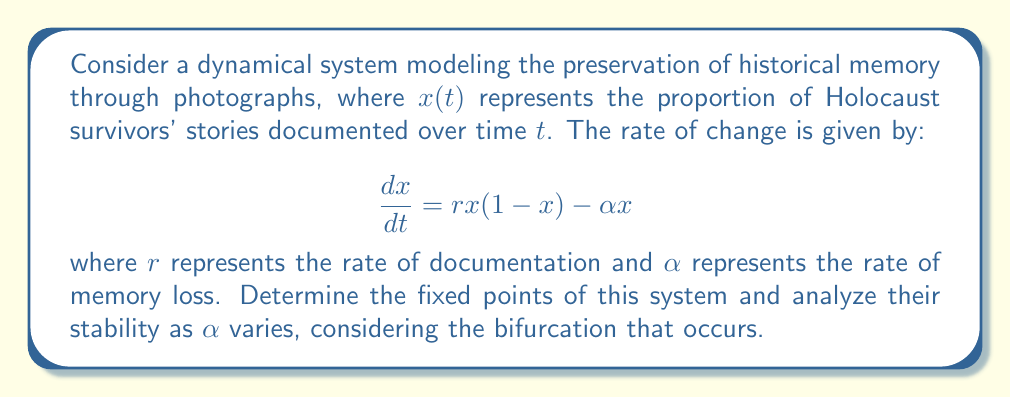Can you answer this question? 1. Find the fixed points by setting $\frac{dx}{dt} = 0$:
   $$rx(1-x) - \alpha x = 0$$
   $$x(r-rx-\alpha) = 0$$
   
   Solving this equation yields two fixed points:
   $x_1 = 0$ and $x_2 = 1 - \frac{\alpha}{r}$

2. Analyze stability by finding the derivative of $\frac{dx}{dt}$ with respect to $x$:
   $$\frac{d}{dx}(\frac{dx}{dt}) = r(1-2x) - \alpha$$

3. Evaluate stability at $x_1 = 0$:
   $$\frac{d}{dx}(\frac{dx}{dt})|_{x=0} = r - \alpha$$
   Stable when $r - \alpha < 0$, i.e., $\alpha > r$

4. Evaluate stability at $x_2 = 1 - \frac{\alpha}{r}$:
   $$\frac{d}{dx}(\frac{dx}{dt})|_{x=1-\frac{\alpha}{r}} = r(1-2(1-\frac{\alpha}{r})) - \alpha = \alpha - r$$
   Stable when $\alpha - r < 0$, i.e., $\alpha < r$

5. Bifurcation analysis:
   A transcritical bifurcation occurs when $\alpha = r$. At this point, the two fixed points exchange stability.

   - For $\alpha < r$: $x_1 = 0$ is unstable, $x_2 = 1 - \frac{\alpha}{r}$ is stable
   - For $\alpha > r$: $x_1 = 0$ is stable, $x_2 = 1 - \frac{\alpha}{r}$ is unstable (and negative)
   - At $\alpha = r$: Both fixed points coincide at $x = 0$

This bifurcation represents a critical point where the rate of memory loss equals the rate of documentation, potentially leading to a sudden shift in the preservation of historical memory.
Answer: Transcritical bifurcation at $\alpha = r$ 